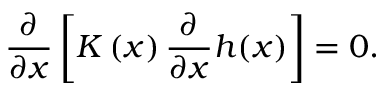Convert formula to latex. <formula><loc_0><loc_0><loc_500><loc_500>\frac { \partial } { { \partial { x } } } \left [ { K \left ( x \right ) \frac { \partial } \partial x } h ( x ) } \right ] = 0 .</formula> 